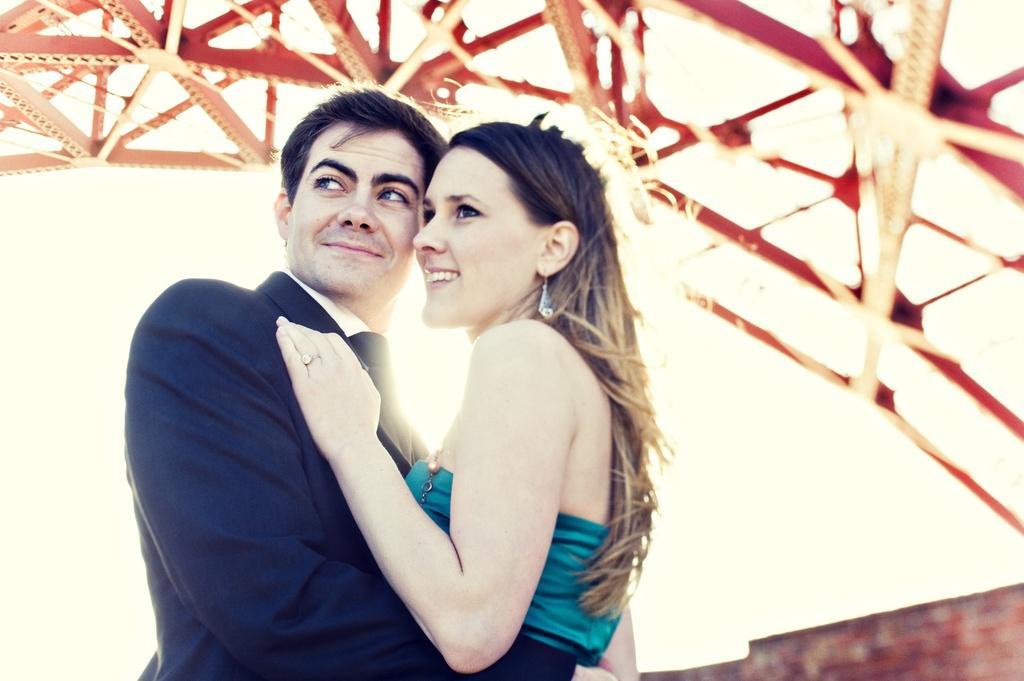Describe this image in one or two sentences. This picture seems to be clicked outside. On the right we can see a woman smiling and standing. On the left we can see a man wearing a suit, smiling and standing and both of them are hugging each other. In the background we can see the metal rods and some other objects. 